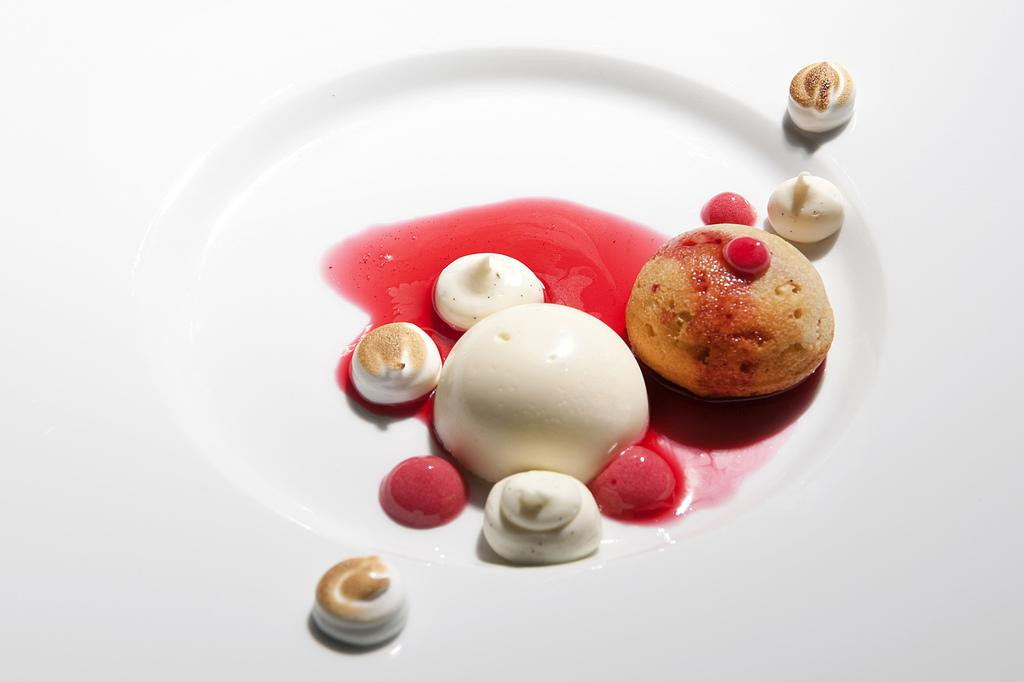What is the main subject of the image? There is a food item on a plate in the image. How does the food item on the plate change its color in the image? The food item on the plate does not change its color in the image; it remains the same color throughout. 